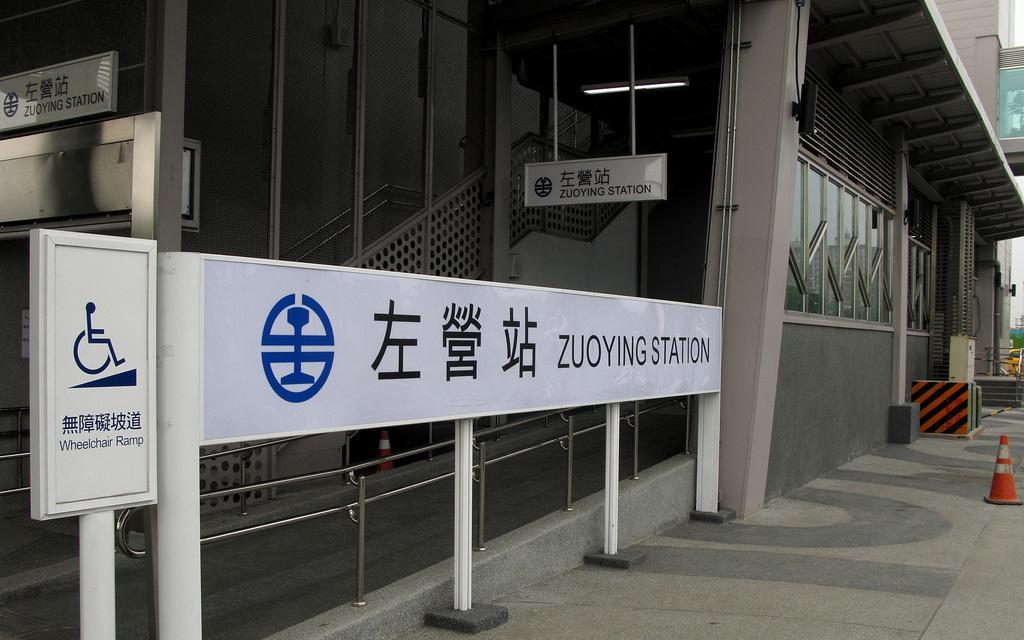Can you describe this image briefly? In this image there is a pavement, in the background there is a building and there is a board, on that board there is some text. 